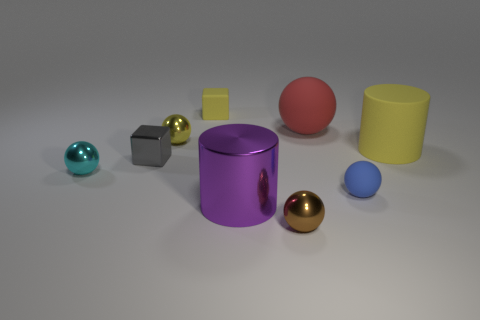Does the tiny yellow thing that is behind the yellow metal sphere have the same material as the tiny gray block in front of the big red matte sphere?
Your answer should be very brief. No. There is a purple thing; what shape is it?
Give a very brief answer. Cylinder. Are there more yellow spheres that are behind the big purple shiny object than large purple shiny cylinders on the right side of the brown sphere?
Your response must be concise. Yes. There is a tiny object in front of the purple cylinder; is it the same shape as the tiny rubber object right of the purple shiny cylinder?
Give a very brief answer. Yes. What number of other objects are the same size as the brown ball?
Keep it short and to the point. 5. The shiny cube has what size?
Offer a terse response. Small. Do the cylinder that is in front of the big yellow cylinder and the large red ball have the same material?
Provide a short and direct response. No. There is another large object that is the same shape as the cyan object; what is its color?
Ensure brevity in your answer.  Red. There is a small cube behind the tiny yellow metal sphere; does it have the same color as the tiny shiny block?
Ensure brevity in your answer.  No. Are there any small blocks to the left of the red object?
Provide a short and direct response. Yes. 